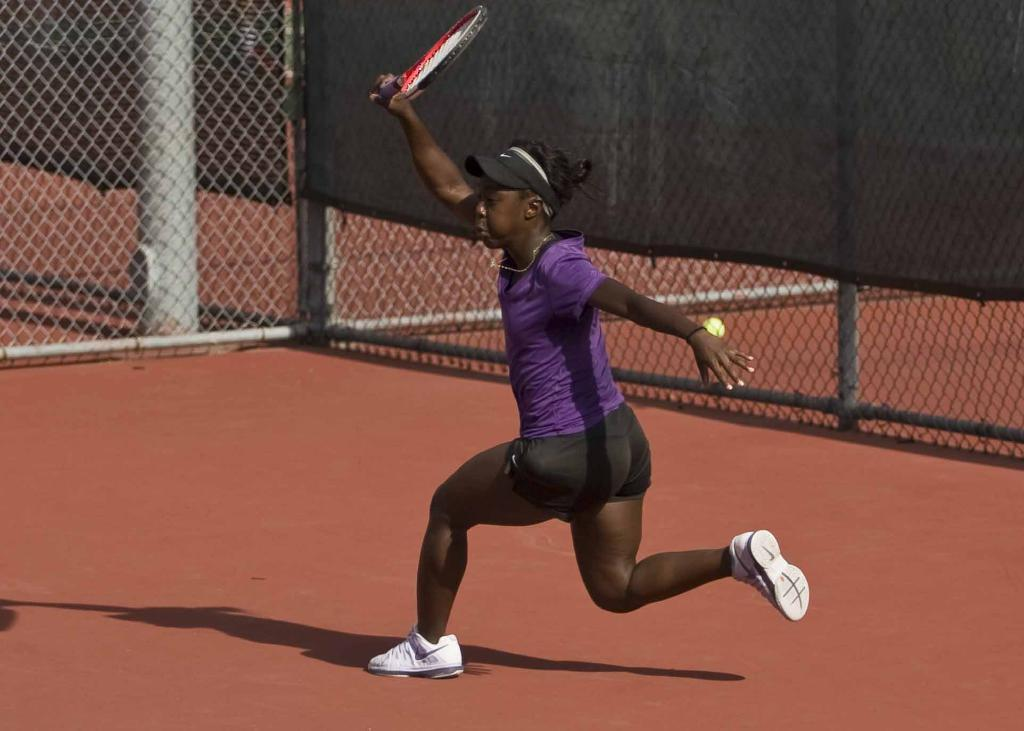What color is the floor in the image? The floor in the image is brown. Who is present in the image? There is a woman in the image. What is the woman holding in the image? The woman is holding a bat. What is the woman doing in the image? The woman is running. What can be seen in the background of the image? There is a black fence in the background of the image. What type of stem can be seen growing from the woman's head in the image? There is no stem growing from the woman's head in the image. What time of day is it in the image, based on the hour? The provided facts do not mention the time of day or any specific hour, so it cannot be determined from the image. 